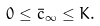<formula> <loc_0><loc_0><loc_500><loc_500>0 \leq \bar { c } _ { \infty } \leq K .</formula> 